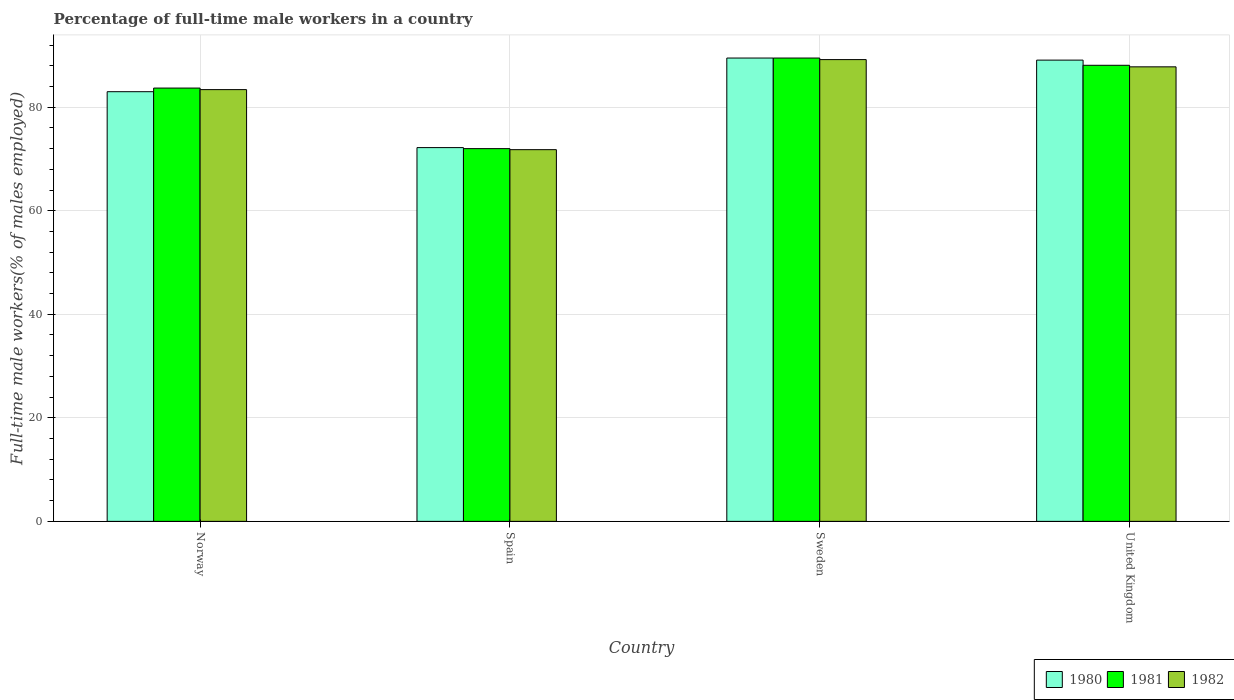How many groups of bars are there?
Keep it short and to the point. 4. Are the number of bars per tick equal to the number of legend labels?
Keep it short and to the point. Yes. Are the number of bars on each tick of the X-axis equal?
Provide a short and direct response. Yes. How many bars are there on the 1st tick from the left?
Give a very brief answer. 3. How many bars are there on the 1st tick from the right?
Offer a very short reply. 3. What is the percentage of full-time male workers in 1981 in Sweden?
Give a very brief answer. 89.5. Across all countries, what is the maximum percentage of full-time male workers in 1982?
Provide a short and direct response. 89.2. Across all countries, what is the minimum percentage of full-time male workers in 1980?
Make the answer very short. 72.2. In which country was the percentage of full-time male workers in 1982 minimum?
Make the answer very short. Spain. What is the total percentage of full-time male workers in 1980 in the graph?
Offer a terse response. 333.8. What is the difference between the percentage of full-time male workers in 1980 in Spain and that in United Kingdom?
Offer a very short reply. -16.9. What is the average percentage of full-time male workers in 1981 per country?
Give a very brief answer. 83.32. What is the difference between the percentage of full-time male workers of/in 1982 and percentage of full-time male workers of/in 1980 in Sweden?
Keep it short and to the point. -0.3. In how many countries, is the percentage of full-time male workers in 1982 greater than 68 %?
Your answer should be compact. 4. What is the ratio of the percentage of full-time male workers in 1982 in Norway to that in Spain?
Your response must be concise. 1.16. Is the difference between the percentage of full-time male workers in 1982 in Spain and Sweden greater than the difference between the percentage of full-time male workers in 1980 in Spain and Sweden?
Keep it short and to the point. No. What is the difference between the highest and the second highest percentage of full-time male workers in 1981?
Offer a terse response. -1.4. What is the difference between the highest and the lowest percentage of full-time male workers in 1982?
Your answer should be compact. 17.4. In how many countries, is the percentage of full-time male workers in 1982 greater than the average percentage of full-time male workers in 1982 taken over all countries?
Your response must be concise. 3. Is the sum of the percentage of full-time male workers in 1980 in Norway and Spain greater than the maximum percentage of full-time male workers in 1982 across all countries?
Your response must be concise. Yes. What does the 3rd bar from the left in Spain represents?
Your answer should be very brief. 1982. Are all the bars in the graph horizontal?
Offer a very short reply. No. Are the values on the major ticks of Y-axis written in scientific E-notation?
Your answer should be compact. No. Does the graph contain any zero values?
Keep it short and to the point. No. Does the graph contain grids?
Ensure brevity in your answer.  Yes. Where does the legend appear in the graph?
Your response must be concise. Bottom right. How are the legend labels stacked?
Give a very brief answer. Horizontal. What is the title of the graph?
Your answer should be very brief. Percentage of full-time male workers in a country. What is the label or title of the X-axis?
Your response must be concise. Country. What is the label or title of the Y-axis?
Offer a very short reply. Full-time male workers(% of males employed). What is the Full-time male workers(% of males employed) of 1980 in Norway?
Your response must be concise. 83. What is the Full-time male workers(% of males employed) of 1981 in Norway?
Provide a short and direct response. 83.7. What is the Full-time male workers(% of males employed) in 1982 in Norway?
Your response must be concise. 83.4. What is the Full-time male workers(% of males employed) in 1980 in Spain?
Your response must be concise. 72.2. What is the Full-time male workers(% of males employed) in 1981 in Spain?
Offer a very short reply. 72. What is the Full-time male workers(% of males employed) of 1982 in Spain?
Keep it short and to the point. 71.8. What is the Full-time male workers(% of males employed) of 1980 in Sweden?
Give a very brief answer. 89.5. What is the Full-time male workers(% of males employed) of 1981 in Sweden?
Your answer should be compact. 89.5. What is the Full-time male workers(% of males employed) in 1982 in Sweden?
Ensure brevity in your answer.  89.2. What is the Full-time male workers(% of males employed) in 1980 in United Kingdom?
Offer a terse response. 89.1. What is the Full-time male workers(% of males employed) in 1981 in United Kingdom?
Keep it short and to the point. 88.1. What is the Full-time male workers(% of males employed) in 1982 in United Kingdom?
Make the answer very short. 87.8. Across all countries, what is the maximum Full-time male workers(% of males employed) in 1980?
Provide a short and direct response. 89.5. Across all countries, what is the maximum Full-time male workers(% of males employed) in 1981?
Provide a short and direct response. 89.5. Across all countries, what is the maximum Full-time male workers(% of males employed) of 1982?
Your answer should be compact. 89.2. Across all countries, what is the minimum Full-time male workers(% of males employed) in 1980?
Provide a succinct answer. 72.2. Across all countries, what is the minimum Full-time male workers(% of males employed) of 1981?
Your answer should be compact. 72. Across all countries, what is the minimum Full-time male workers(% of males employed) in 1982?
Your answer should be compact. 71.8. What is the total Full-time male workers(% of males employed) in 1980 in the graph?
Ensure brevity in your answer.  333.8. What is the total Full-time male workers(% of males employed) of 1981 in the graph?
Your response must be concise. 333.3. What is the total Full-time male workers(% of males employed) of 1982 in the graph?
Give a very brief answer. 332.2. What is the difference between the Full-time male workers(% of males employed) of 1980 in Norway and that in Spain?
Ensure brevity in your answer.  10.8. What is the difference between the Full-time male workers(% of males employed) of 1981 in Norway and that in Spain?
Provide a succinct answer. 11.7. What is the difference between the Full-time male workers(% of males employed) in 1982 in Norway and that in Spain?
Offer a terse response. 11.6. What is the difference between the Full-time male workers(% of males employed) of 1980 in Norway and that in Sweden?
Your answer should be compact. -6.5. What is the difference between the Full-time male workers(% of males employed) of 1980 in Norway and that in United Kingdom?
Provide a short and direct response. -6.1. What is the difference between the Full-time male workers(% of males employed) of 1981 in Norway and that in United Kingdom?
Ensure brevity in your answer.  -4.4. What is the difference between the Full-time male workers(% of males employed) of 1980 in Spain and that in Sweden?
Keep it short and to the point. -17.3. What is the difference between the Full-time male workers(% of males employed) in 1981 in Spain and that in Sweden?
Offer a terse response. -17.5. What is the difference between the Full-time male workers(% of males employed) of 1982 in Spain and that in Sweden?
Your response must be concise. -17.4. What is the difference between the Full-time male workers(% of males employed) in 1980 in Spain and that in United Kingdom?
Give a very brief answer. -16.9. What is the difference between the Full-time male workers(% of males employed) in 1981 in Spain and that in United Kingdom?
Give a very brief answer. -16.1. What is the difference between the Full-time male workers(% of males employed) in 1982 in Spain and that in United Kingdom?
Provide a short and direct response. -16. What is the difference between the Full-time male workers(% of males employed) of 1980 in Sweden and that in United Kingdom?
Give a very brief answer. 0.4. What is the difference between the Full-time male workers(% of males employed) of 1980 in Norway and the Full-time male workers(% of males employed) of 1981 in Spain?
Make the answer very short. 11. What is the difference between the Full-time male workers(% of males employed) in 1981 in Norway and the Full-time male workers(% of males employed) in 1982 in Spain?
Provide a succinct answer. 11.9. What is the difference between the Full-time male workers(% of males employed) of 1980 in Norway and the Full-time male workers(% of males employed) of 1982 in Sweden?
Keep it short and to the point. -6.2. What is the difference between the Full-time male workers(% of males employed) of 1980 in Norway and the Full-time male workers(% of males employed) of 1981 in United Kingdom?
Provide a short and direct response. -5.1. What is the difference between the Full-time male workers(% of males employed) of 1981 in Norway and the Full-time male workers(% of males employed) of 1982 in United Kingdom?
Your answer should be very brief. -4.1. What is the difference between the Full-time male workers(% of males employed) of 1980 in Spain and the Full-time male workers(% of males employed) of 1981 in Sweden?
Keep it short and to the point. -17.3. What is the difference between the Full-time male workers(% of males employed) in 1980 in Spain and the Full-time male workers(% of males employed) in 1982 in Sweden?
Make the answer very short. -17. What is the difference between the Full-time male workers(% of males employed) in 1981 in Spain and the Full-time male workers(% of males employed) in 1982 in Sweden?
Give a very brief answer. -17.2. What is the difference between the Full-time male workers(% of males employed) in 1980 in Spain and the Full-time male workers(% of males employed) in 1981 in United Kingdom?
Provide a short and direct response. -15.9. What is the difference between the Full-time male workers(% of males employed) in 1980 in Spain and the Full-time male workers(% of males employed) in 1982 in United Kingdom?
Provide a succinct answer. -15.6. What is the difference between the Full-time male workers(% of males employed) of 1981 in Spain and the Full-time male workers(% of males employed) of 1982 in United Kingdom?
Keep it short and to the point. -15.8. What is the difference between the Full-time male workers(% of males employed) in 1980 in Sweden and the Full-time male workers(% of males employed) in 1981 in United Kingdom?
Provide a short and direct response. 1.4. What is the difference between the Full-time male workers(% of males employed) of 1980 in Sweden and the Full-time male workers(% of males employed) of 1982 in United Kingdom?
Give a very brief answer. 1.7. What is the average Full-time male workers(% of males employed) of 1980 per country?
Give a very brief answer. 83.45. What is the average Full-time male workers(% of males employed) in 1981 per country?
Give a very brief answer. 83.33. What is the average Full-time male workers(% of males employed) of 1982 per country?
Ensure brevity in your answer.  83.05. What is the difference between the Full-time male workers(% of males employed) of 1981 and Full-time male workers(% of males employed) of 1982 in Norway?
Provide a succinct answer. 0.3. What is the difference between the Full-time male workers(% of males employed) of 1980 and Full-time male workers(% of males employed) of 1982 in Spain?
Ensure brevity in your answer.  0.4. What is the difference between the Full-time male workers(% of males employed) of 1981 and Full-time male workers(% of males employed) of 1982 in Spain?
Keep it short and to the point. 0.2. What is the difference between the Full-time male workers(% of males employed) of 1980 and Full-time male workers(% of males employed) of 1981 in Sweden?
Your answer should be very brief. 0. What is the difference between the Full-time male workers(% of males employed) of 1981 and Full-time male workers(% of males employed) of 1982 in Sweden?
Offer a terse response. 0.3. What is the difference between the Full-time male workers(% of males employed) in 1980 and Full-time male workers(% of males employed) in 1981 in United Kingdom?
Offer a very short reply. 1. What is the ratio of the Full-time male workers(% of males employed) in 1980 in Norway to that in Spain?
Ensure brevity in your answer.  1.15. What is the ratio of the Full-time male workers(% of males employed) of 1981 in Norway to that in Spain?
Make the answer very short. 1.16. What is the ratio of the Full-time male workers(% of males employed) in 1982 in Norway to that in Spain?
Your response must be concise. 1.16. What is the ratio of the Full-time male workers(% of males employed) in 1980 in Norway to that in Sweden?
Make the answer very short. 0.93. What is the ratio of the Full-time male workers(% of males employed) of 1981 in Norway to that in Sweden?
Give a very brief answer. 0.94. What is the ratio of the Full-time male workers(% of males employed) in 1982 in Norway to that in Sweden?
Keep it short and to the point. 0.94. What is the ratio of the Full-time male workers(% of males employed) of 1980 in Norway to that in United Kingdom?
Ensure brevity in your answer.  0.93. What is the ratio of the Full-time male workers(% of males employed) in 1981 in Norway to that in United Kingdom?
Your answer should be very brief. 0.95. What is the ratio of the Full-time male workers(% of males employed) of 1982 in Norway to that in United Kingdom?
Your answer should be very brief. 0.95. What is the ratio of the Full-time male workers(% of males employed) in 1980 in Spain to that in Sweden?
Offer a very short reply. 0.81. What is the ratio of the Full-time male workers(% of males employed) in 1981 in Spain to that in Sweden?
Your answer should be compact. 0.8. What is the ratio of the Full-time male workers(% of males employed) in 1982 in Spain to that in Sweden?
Offer a terse response. 0.8. What is the ratio of the Full-time male workers(% of males employed) in 1980 in Spain to that in United Kingdom?
Give a very brief answer. 0.81. What is the ratio of the Full-time male workers(% of males employed) in 1981 in Spain to that in United Kingdom?
Make the answer very short. 0.82. What is the ratio of the Full-time male workers(% of males employed) in 1982 in Spain to that in United Kingdom?
Offer a very short reply. 0.82. What is the ratio of the Full-time male workers(% of males employed) of 1981 in Sweden to that in United Kingdom?
Offer a terse response. 1.02. What is the ratio of the Full-time male workers(% of males employed) of 1982 in Sweden to that in United Kingdom?
Your response must be concise. 1.02. What is the difference between the highest and the second highest Full-time male workers(% of males employed) of 1980?
Provide a short and direct response. 0.4. What is the difference between the highest and the second highest Full-time male workers(% of males employed) in 1982?
Offer a terse response. 1.4. What is the difference between the highest and the lowest Full-time male workers(% of males employed) of 1981?
Make the answer very short. 17.5. What is the difference between the highest and the lowest Full-time male workers(% of males employed) in 1982?
Ensure brevity in your answer.  17.4. 